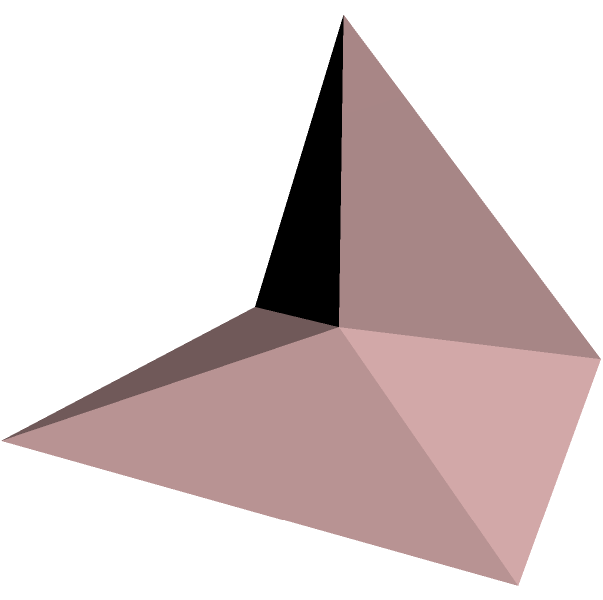A boutique jewelry store in Laguna Beach wants to create a pyramidal display stand for their new collection. The base of the stand is a square with sides measuring 10 cm, and the height of the pyramid is 8 cm. What is the volume of this pyramidal display stand in cubic centimeters? To calculate the volume of a pyramid, we use the formula:

$$V = \frac{1}{3} \times B \times h$$

Where:
$V$ = volume
$B$ = area of the base
$h$ = height of the pyramid

Step 1: Calculate the area of the base (B)
The base is a square with sides of 10 cm.
$$B = 10 \text{ cm} \times 10 \text{ cm} = 100 \text{ cm}^2$$

Step 2: Use the volume formula
$$V = \frac{1}{3} \times B \times h$$
$$V = \frac{1}{3} \times 100 \text{ cm}^2 \times 8 \text{ cm}$$

Step 3: Solve the equation
$$V = \frac{800}{3} \text{ cm}^3$$
$$V \approx 266.67 \text{ cm}^3$$

Therefore, the volume of the pyramidal display stand is approximately 266.67 cubic centimeters.
Answer: 266.67 cm³ 